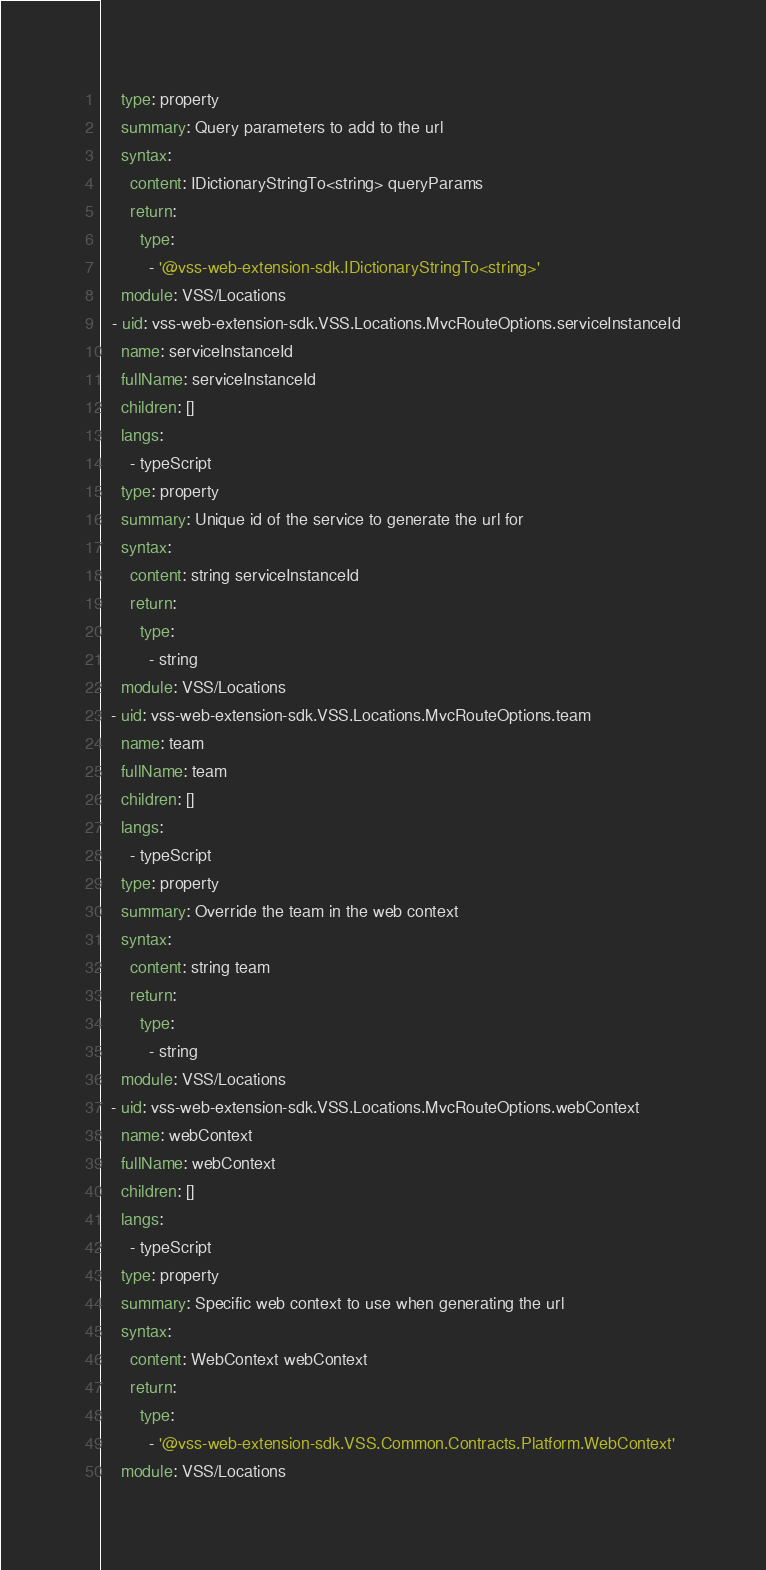Convert code to text. <code><loc_0><loc_0><loc_500><loc_500><_YAML_>    type: property
    summary: Query parameters to add to the url
    syntax:
      content: IDictionaryStringTo<string> queryParams
      return:
        type:
          - '@vss-web-extension-sdk.IDictionaryStringTo<string>'
    module: VSS/Locations
  - uid: vss-web-extension-sdk.VSS.Locations.MvcRouteOptions.serviceInstanceId
    name: serviceInstanceId
    fullName: serviceInstanceId
    children: []
    langs:
      - typeScript
    type: property
    summary: Unique id of the service to generate the url for
    syntax:
      content: string serviceInstanceId
      return:
        type:
          - string
    module: VSS/Locations
  - uid: vss-web-extension-sdk.VSS.Locations.MvcRouteOptions.team
    name: team
    fullName: team
    children: []
    langs:
      - typeScript
    type: property
    summary: Override the team in the web context
    syntax:
      content: string team
      return:
        type:
          - string
    module: VSS/Locations
  - uid: vss-web-extension-sdk.VSS.Locations.MvcRouteOptions.webContext
    name: webContext
    fullName: webContext
    children: []
    langs:
      - typeScript
    type: property
    summary: Specific web context to use when generating the url
    syntax:
      content: WebContext webContext
      return:
        type:
          - '@vss-web-extension-sdk.VSS.Common.Contracts.Platform.WebContext'
    module: VSS/Locations
</code> 